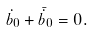<formula> <loc_0><loc_0><loc_500><loc_500>\dot { b } _ { 0 } + \bar { \dot { b } } _ { 0 } = 0 .</formula> 